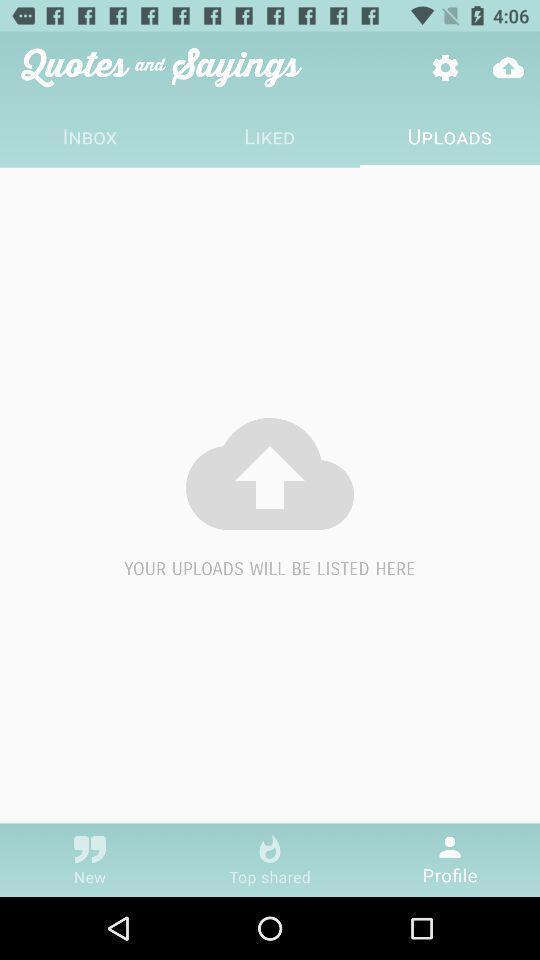Please provide a description for this image. Screen shows uploads details in a communication app. 